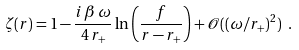Convert formula to latex. <formula><loc_0><loc_0><loc_500><loc_500>\zeta ( r ) = 1 - \frac { i \, \beta \, \omega } { 4 \, r _ { + } } \ln \left ( \frac { f } { r - r _ { + } } \right ) + { \mathcal { O } } ( ( \omega / r _ { + } ) ^ { 2 } ) \ .</formula> 